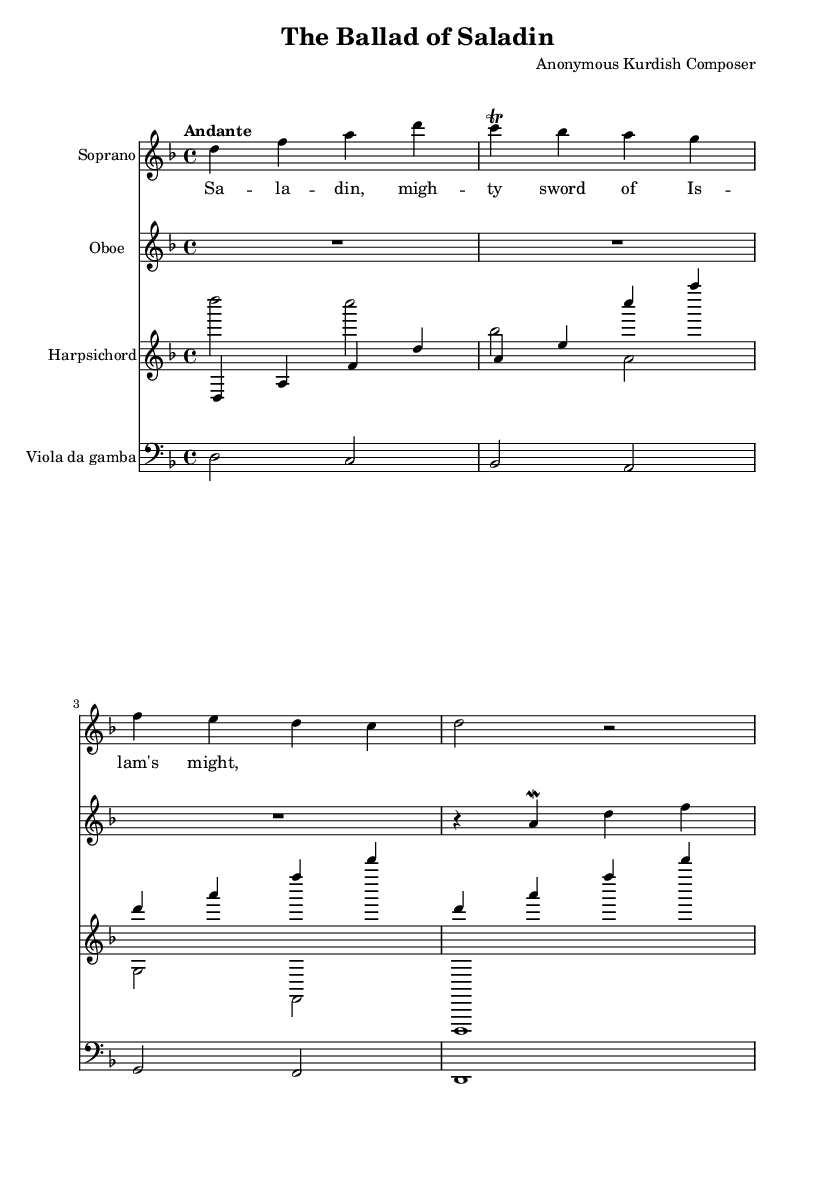What is the key signature of this music? The key signature is D minor, which is indicated by one flat (B flat) at the beginning of the staff.
Answer: D minor What is the time signature of this music? The time signature is 4/4, which is shown at the beginning of the score following the key signature. It indicates that there are four beats per measure.
Answer: 4/4 What is the tempo marking? The tempo marking is "Andante," which is written above the staff, indicating a moderately slow pace.
Answer: Andante How many instruments are scored in this piece? The score includes four instruments: Soprano, Oboe, Harpsichord, and Viola da gamba, as indicated by the respective staves in the score.
Answer: Four What is the main theme presented in the lyrics? The lyrics present the theme of "Saladin," a legendary historical figure, captured in the line "Saladin, mighty sword of Islam's might." This reflects the focus of the opera.
Answer: Saladin Which instrument plays a trill? The Soprano voice part is indicated to have a trill on the note C, which is shown in the music notation.
Answer: Soprano What type of ensemble is represented in the score? The score represents a chamber ensemble with a combination of vocal and instrumental parts typical of Baroque operas.
Answer: Chamber ensemble 